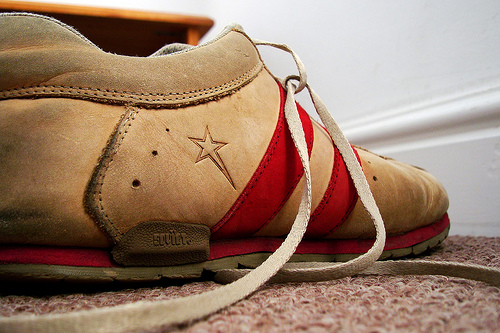<image>
Is the shoe above the floor? No. The shoe is not positioned above the floor. The vertical arrangement shows a different relationship. 